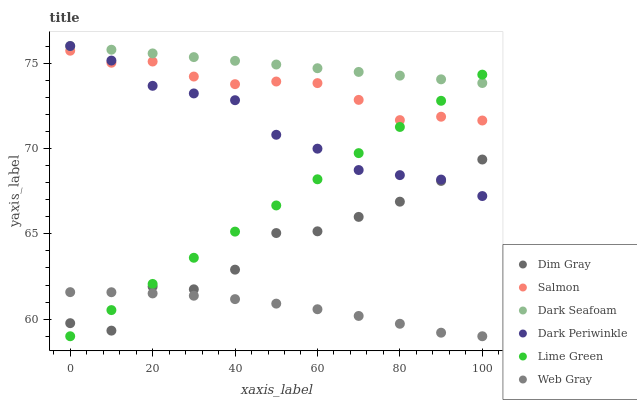Does Web Gray have the minimum area under the curve?
Answer yes or no. Yes. Does Dark Seafoam have the maximum area under the curve?
Answer yes or no. Yes. Does Salmon have the minimum area under the curve?
Answer yes or no. No. Does Salmon have the maximum area under the curve?
Answer yes or no. No. Is Dark Seafoam the smoothest?
Answer yes or no. Yes. Is Dim Gray the roughest?
Answer yes or no. Yes. Is Salmon the smoothest?
Answer yes or no. No. Is Salmon the roughest?
Answer yes or no. No. Does Web Gray have the lowest value?
Answer yes or no. Yes. Does Salmon have the lowest value?
Answer yes or no. No. Does Dark Periwinkle have the highest value?
Answer yes or no. Yes. Does Salmon have the highest value?
Answer yes or no. No. Is Dim Gray less than Salmon?
Answer yes or no. Yes. Is Dark Seafoam greater than Web Gray?
Answer yes or no. Yes. Does Lime Green intersect Dim Gray?
Answer yes or no. Yes. Is Lime Green less than Dim Gray?
Answer yes or no. No. Is Lime Green greater than Dim Gray?
Answer yes or no. No. Does Dim Gray intersect Salmon?
Answer yes or no. No. 